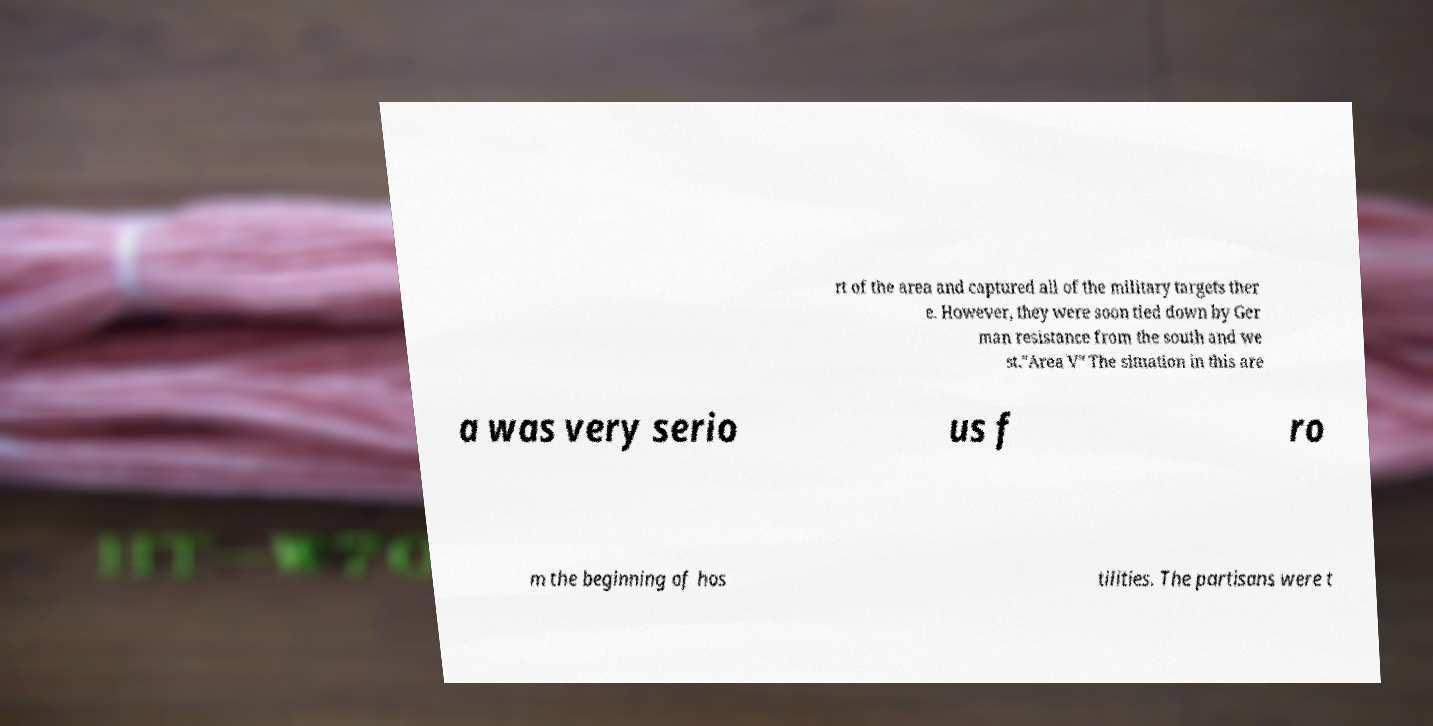Please read and relay the text visible in this image. What does it say? rt of the area and captured all of the military targets ther e. However, they were soon tied down by Ger man resistance from the south and we st."Area V" The situation in this are a was very serio us f ro m the beginning of hos tilities. The partisans were t 